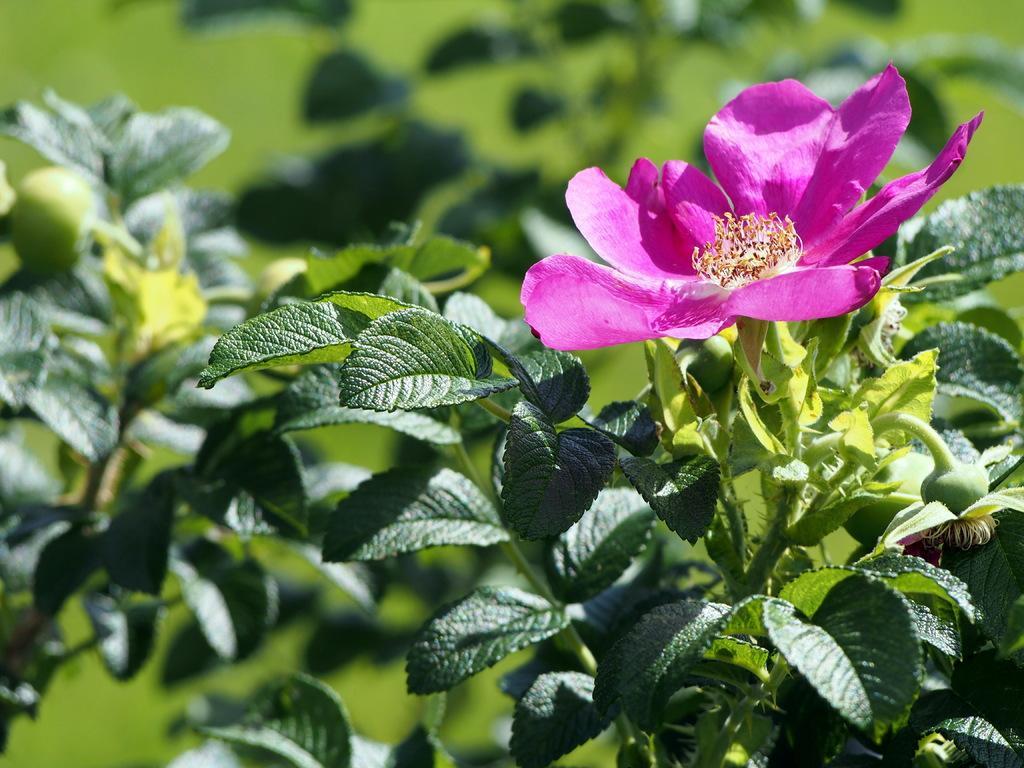Can you describe this image briefly? In this image we can see some plants with pink flowers. 